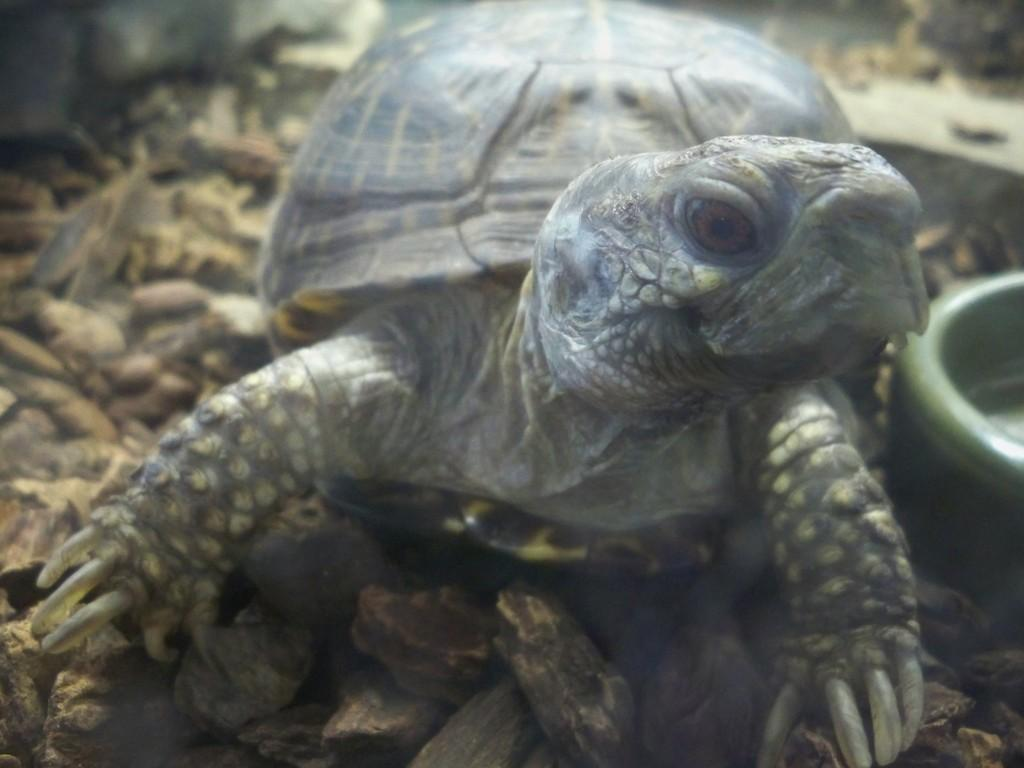What animal can be seen in the image? There is a turtle in the image. What green object is present in the image? There is a green object that looks like a bowl in the image. What can be seen in the background of the image? Small stones are visible in the background of the image. What type of apparel is the turtle wearing in the image? There is no apparel visible on the turtle in the image. What sound can be heard coming from the stove in the image? There is no stove present in the image, so no sound can be heard. 